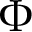Convert formula to latex. <formula><loc_0><loc_0><loc_500><loc_500>\Phi</formula> 